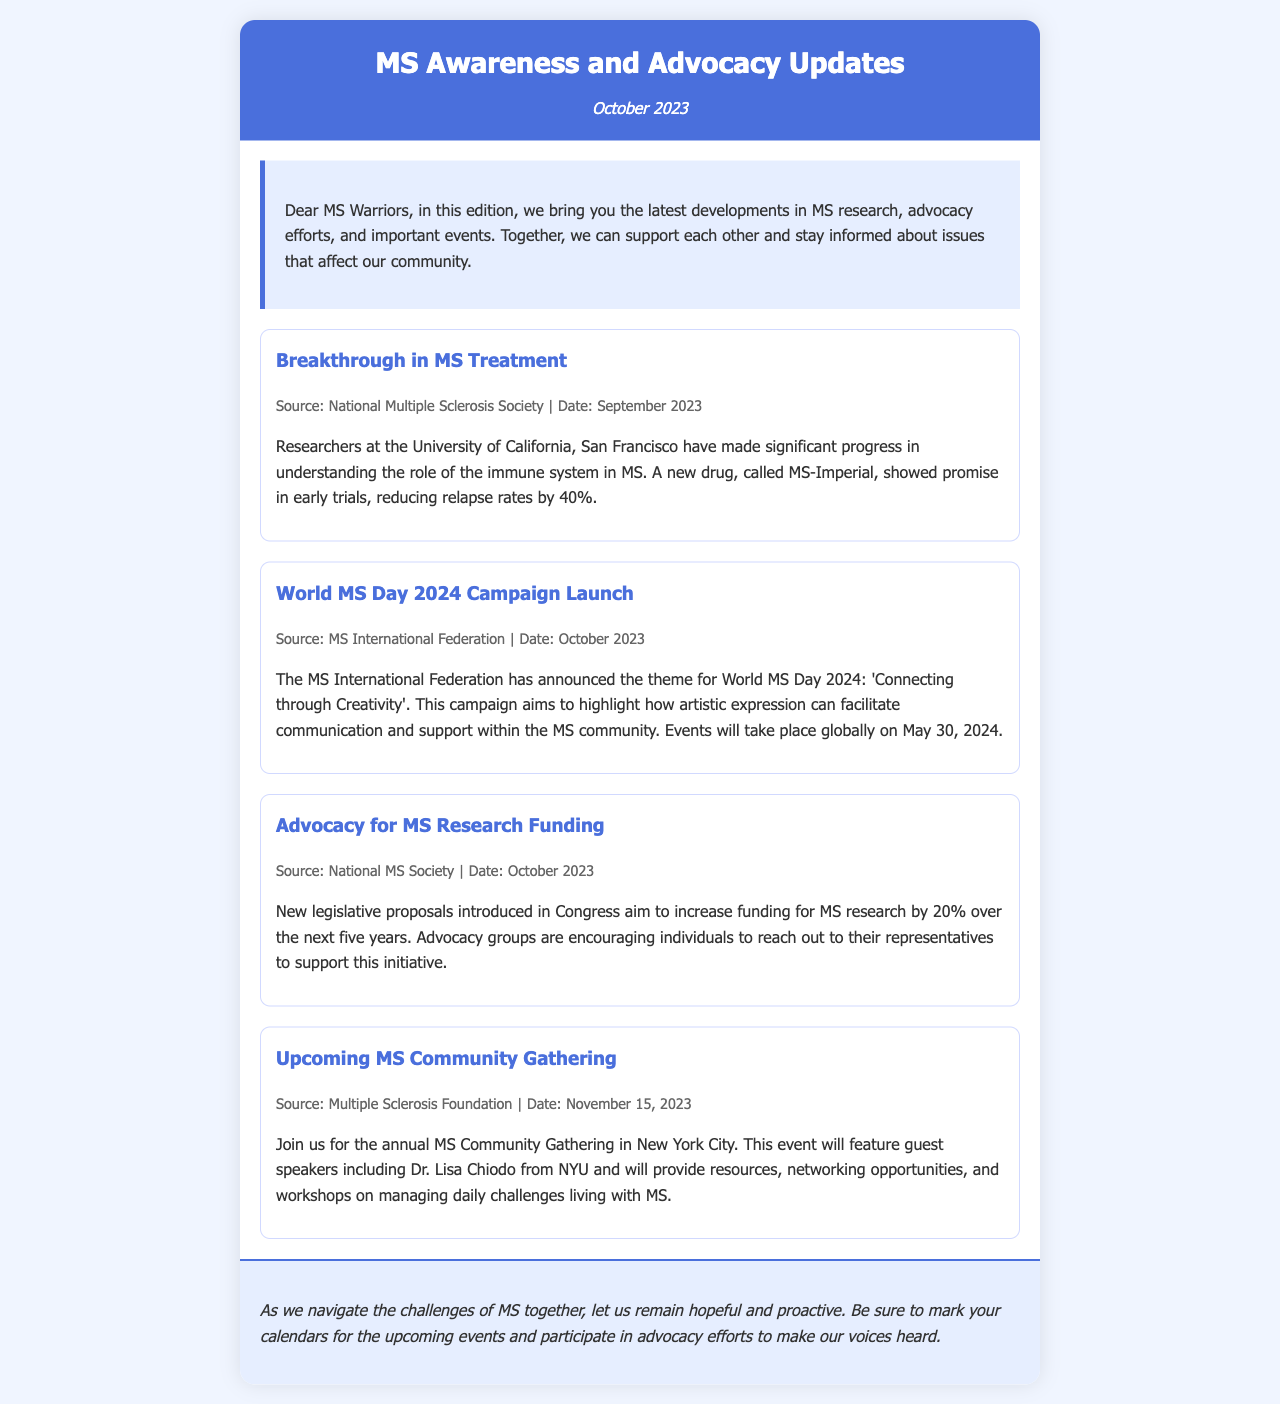What is the theme for World MS Day 2024? The theme for World MS Day 2024 is mentioned in the document as 'Connecting through Creativity'.
Answer: Connecting through Creativity What is the name of the new drug showing promise in early trials? The new drug that showed promise in early trials is stated as MS-Imperial.
Answer: MS-Imperial When is the annual MS Community Gathering scheduled? The document provides the date for the annual MS Community Gathering as November 15, 2023.
Answer: November 15, 2023 What percentage is MS research funding proposed to increase by? The proposal aims to increase MS research funding by 20%.
Answer: 20% Who is the guest speaker mentioned for the MS Community Gathering? The guest speaker listed for the event is Dr. Lisa Chiodo from NYU.
Answer: Dr. Lisa Chiodo When did the breakthrough in MS treatment announcement occur? The breakthrough in MS treatment was reported in September 2023.
Answer: September 2023 Which organization announced the World MS Day campaign? The organization that announced the World MS Day campaign is the MS International Federation.
Answer: MS International Federation What type of updates does this newsletter cover? The newsletter covers updates on MS research, advocacy efforts, and events.
Answer: Research, advocacy efforts, and events 